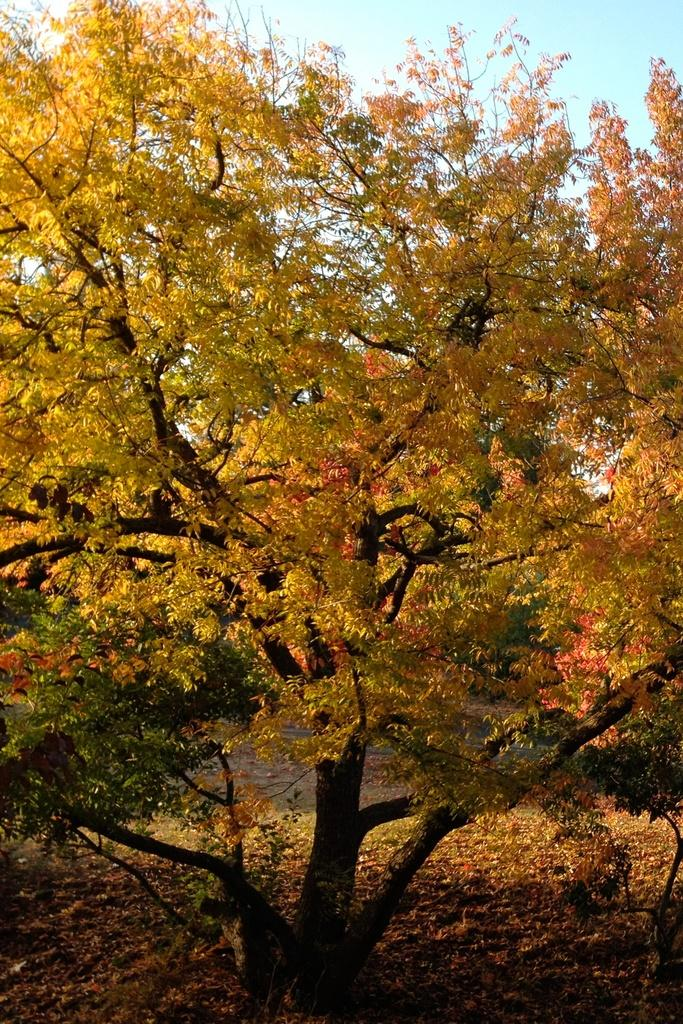What is the main object in the image? There is a tree in the image. What is the condition of the tree? The tree has some leaves fallen on the surface. Can you see the parent of the tree in the image? There is no parent of the tree visible in the image, as the focus is on the tree itself and its fallen leaves. Is there a basketball court near the tree in the image? There is no mention of a basketball court or any sports-related elements in the image, so it cannot be determined from the provided facts. 